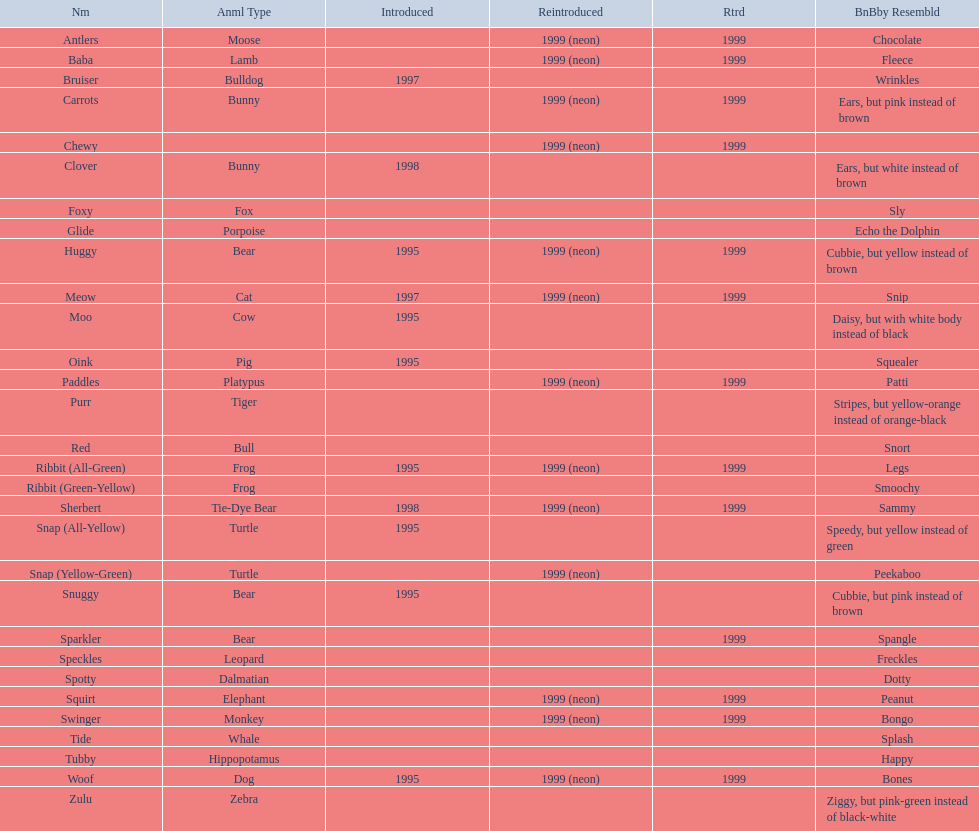Which of the listed pillow pals lack information in at least 3 categories? Chewy, Foxy, Glide, Purr, Red, Ribbit (Green-Yellow), Speckles, Spotty, Tide, Tubby, Zulu. Of those, which one lacks information in the animal type category? Chewy. 